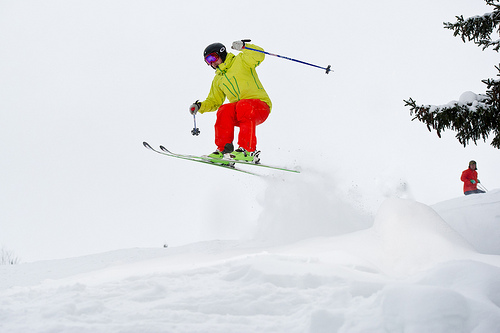Describe the skier's posture and motion. The skier is captured in a dynamic mid-air jump, legs bent and arms outstretched for balance, demonstrating excellent form and control. 